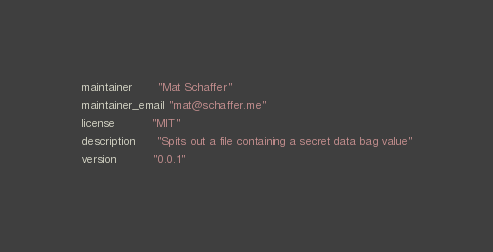<code> <loc_0><loc_0><loc_500><loc_500><_Ruby_>maintainer       "Mat Schaffer"
maintainer_email "mat@schaffer.me"
license          "MIT"
description      "Spits out a file containing a secret data bag value"
version          "0.0.1"
</code> 